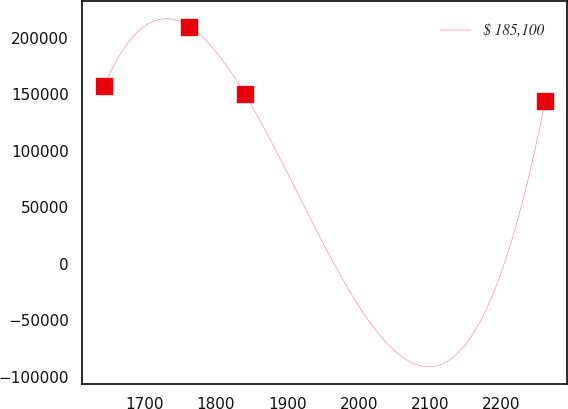<chart> <loc_0><loc_0><loc_500><loc_500><line_chart><ecel><fcel>$ 185,100<nl><fcel>1643.08<fcel>157326<nl><fcel>1762.77<fcel>209971<nl><fcel>1840.05<fcel>150745<nl><fcel>2261.31<fcel>144165<nl></chart> 